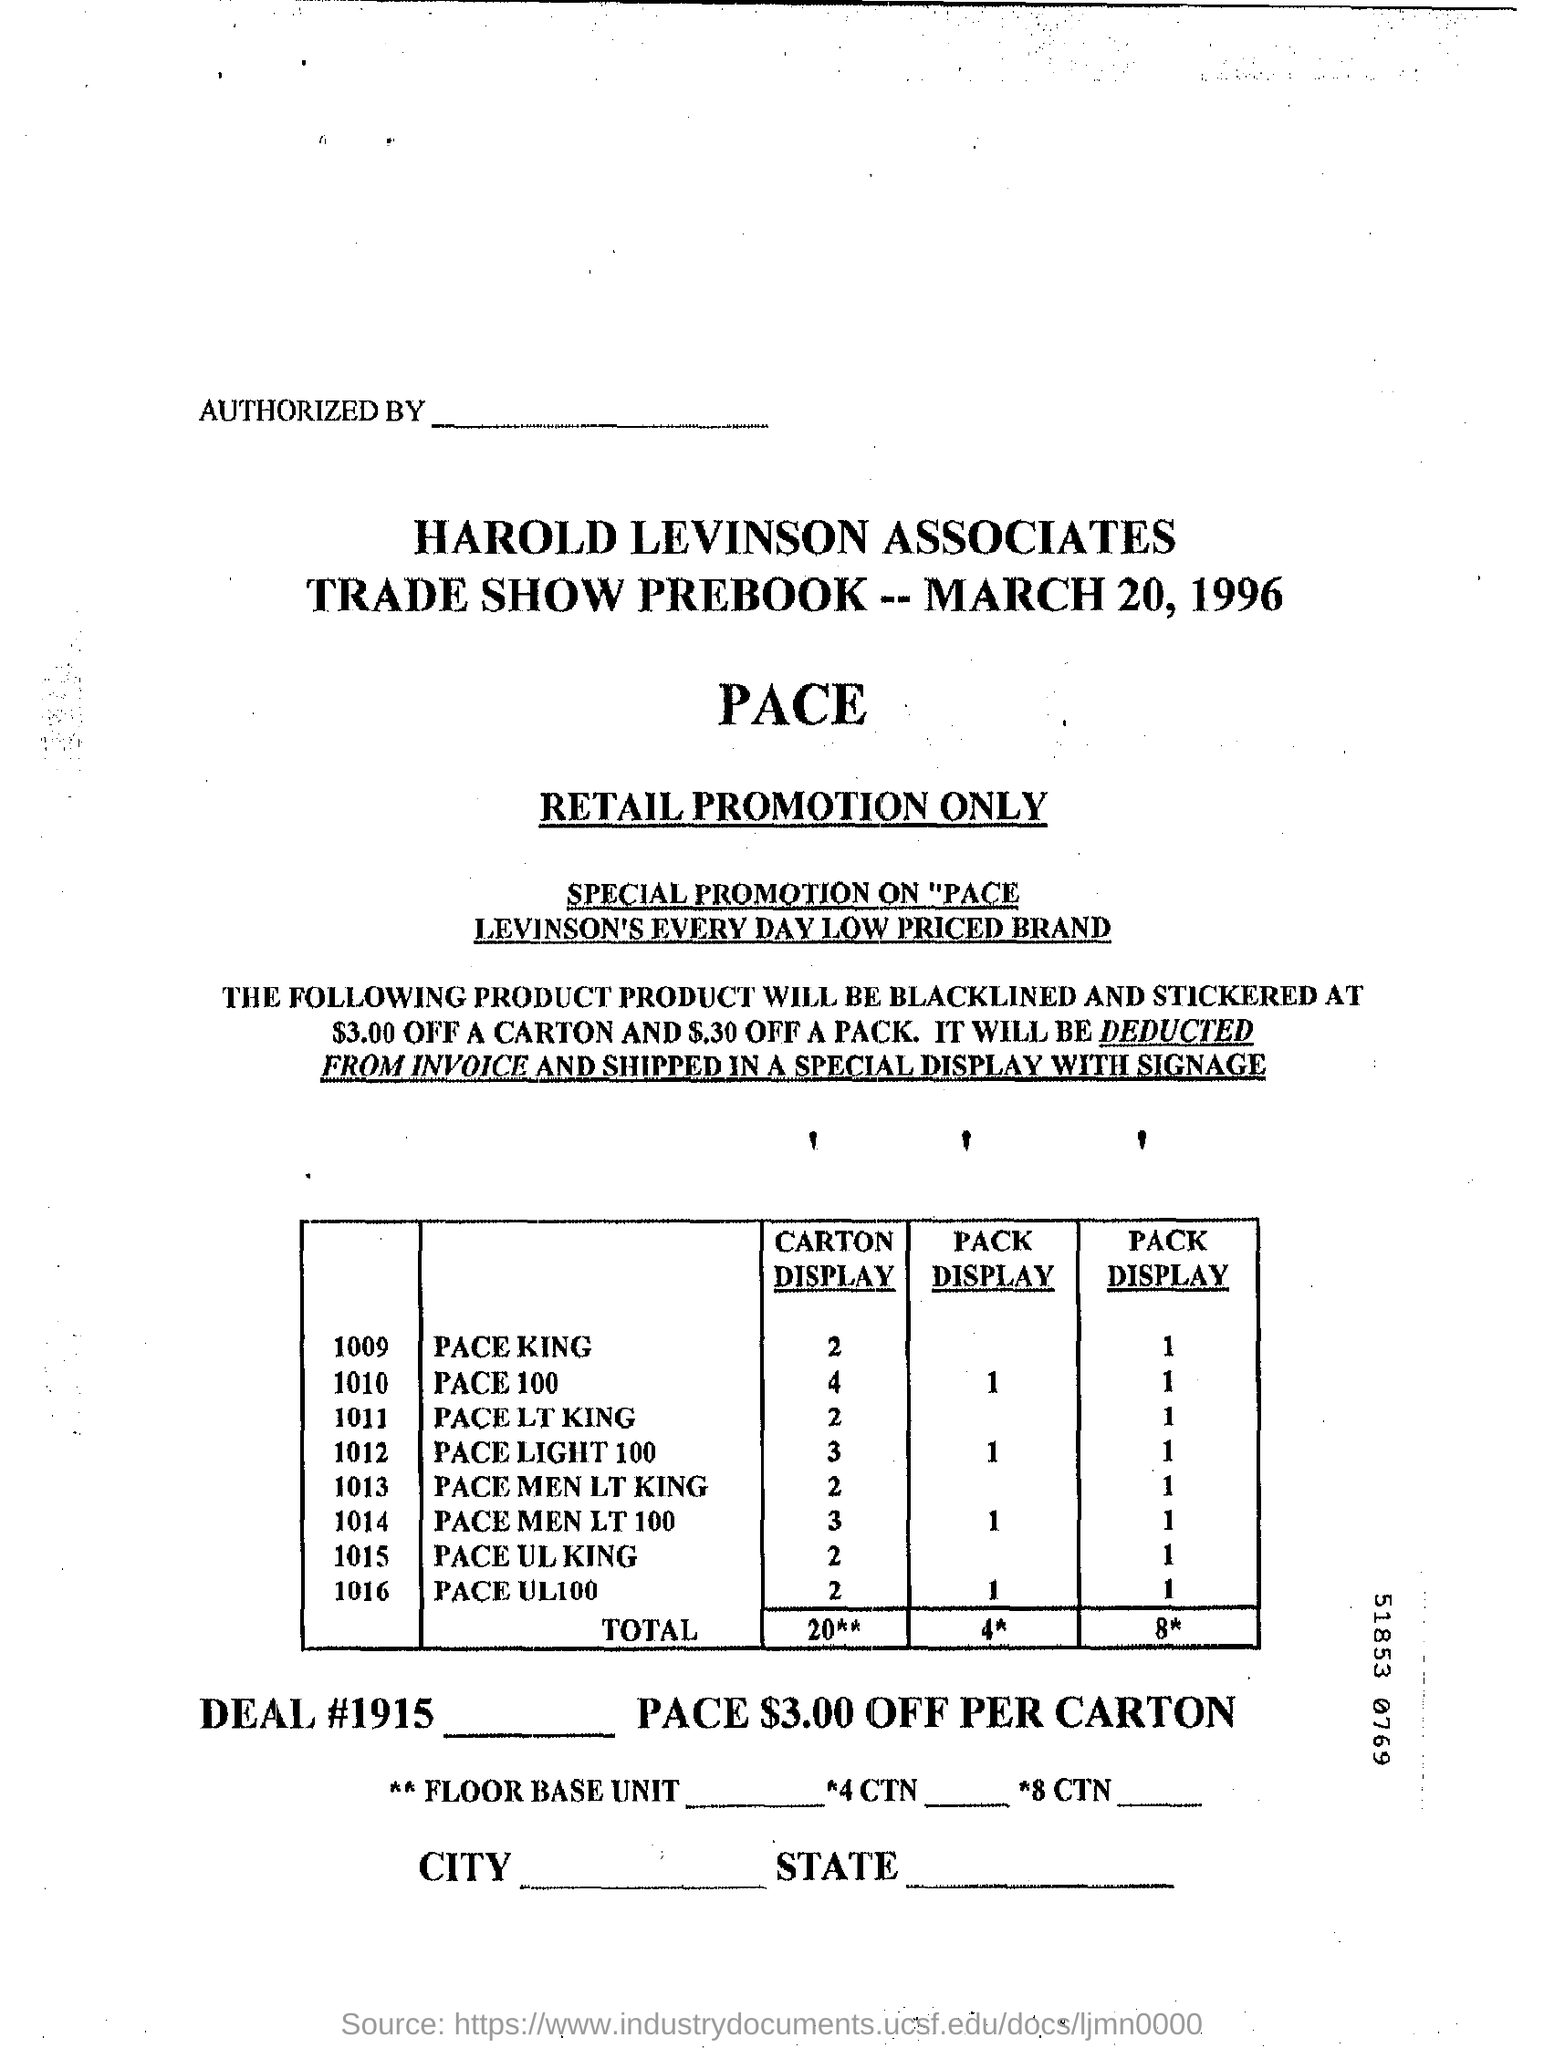What is the date mentioned in the document?
Offer a terse response. March 20, 1996. 